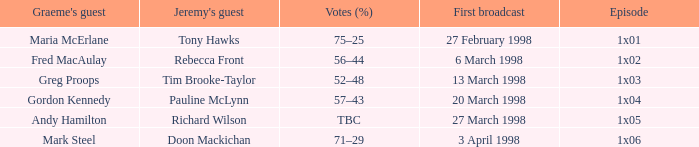What is Votes (%), when Episode is "1x03"? 52–48. 